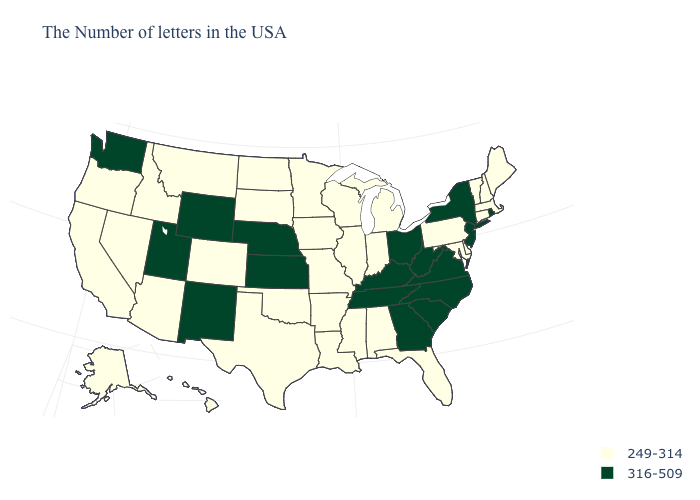What is the value of Maine?
Give a very brief answer. 249-314. What is the value of Idaho?
Keep it brief. 249-314. Name the states that have a value in the range 316-509?
Write a very short answer. Rhode Island, New York, New Jersey, Virginia, North Carolina, South Carolina, West Virginia, Ohio, Georgia, Kentucky, Tennessee, Kansas, Nebraska, Wyoming, New Mexico, Utah, Washington. What is the highest value in the MidWest ?
Write a very short answer. 316-509. Does Idaho have a higher value than North Dakota?
Keep it brief. No. Does the map have missing data?
Give a very brief answer. No. How many symbols are there in the legend?
Quick response, please. 2. Does North Carolina have the same value as New Jersey?
Keep it brief. Yes. What is the value of New Hampshire?
Concise answer only. 249-314. What is the highest value in states that border Delaware?
Be succinct. 316-509. How many symbols are there in the legend?
Answer briefly. 2. Which states have the lowest value in the USA?
Quick response, please. Maine, Massachusetts, New Hampshire, Vermont, Connecticut, Delaware, Maryland, Pennsylvania, Florida, Michigan, Indiana, Alabama, Wisconsin, Illinois, Mississippi, Louisiana, Missouri, Arkansas, Minnesota, Iowa, Oklahoma, Texas, South Dakota, North Dakota, Colorado, Montana, Arizona, Idaho, Nevada, California, Oregon, Alaska, Hawaii. Name the states that have a value in the range 316-509?
Keep it brief. Rhode Island, New York, New Jersey, Virginia, North Carolina, South Carolina, West Virginia, Ohio, Georgia, Kentucky, Tennessee, Kansas, Nebraska, Wyoming, New Mexico, Utah, Washington. How many symbols are there in the legend?
Be succinct. 2. 